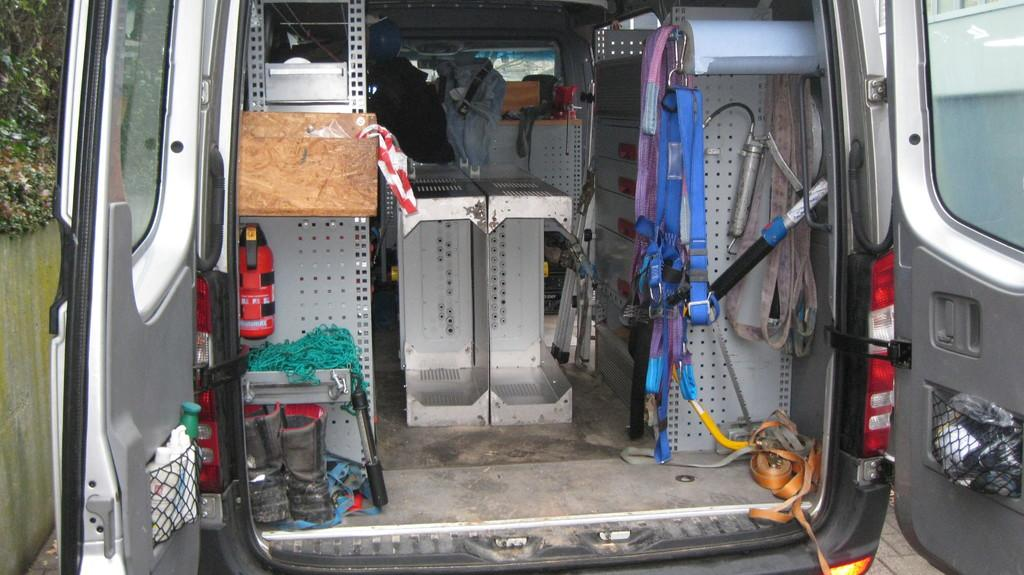Where was the image taken? The image is taken inside a car. What can be seen inside the car? There are some equipment visible in the image. What can be seen on the sides of the car in the image? There is a car door on the left side and a car door on the right side of the image. What type of cover is protecting the car from the fog in the image? There is no fog or cover present in the image; it is taken inside a car with equipment visible. 